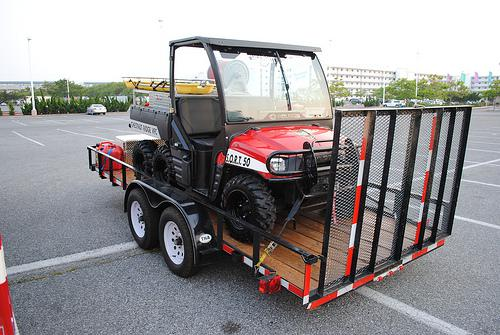Question: who is present?
Choices:
A. A man.
B. A woman.
C. Nobody.
D. A child.
Answer with the letter. Answer: C Question: where was this photo taken?
Choices:
A. In a dirt lot.
B. In a field.
C. In a parking lot.
D. In the street.
Answer with the letter. Answer: C Question: what color is the road?
Choices:
A. Grey.
B. Black.
C. White.
D. Red.
Answer with the letter. Answer: A Question: when was this?
Choices:
A. During the night.
B. Wintertime.
C. Summertime.
D. Daytime.
Answer with the letter. Answer: D 